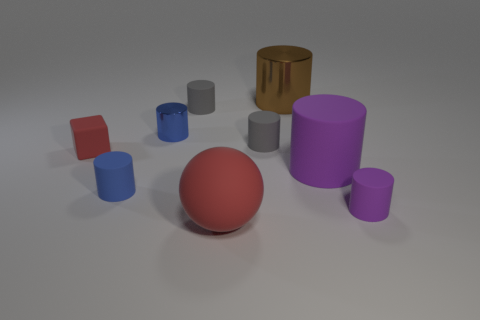Subtract all blue shiny cylinders. How many cylinders are left? 6 Subtract all cubes. How many objects are left? 8 Subtract all purple cylinders. How many cylinders are left? 5 Subtract all green shiny objects. Subtract all big brown shiny objects. How many objects are left? 8 Add 2 large brown shiny things. How many large brown shiny things are left? 3 Add 5 brown things. How many brown things exist? 6 Subtract 0 purple blocks. How many objects are left? 9 Subtract 4 cylinders. How many cylinders are left? 3 Subtract all gray cylinders. Subtract all cyan cubes. How many cylinders are left? 5 Subtract all red balls. How many green cylinders are left? 0 